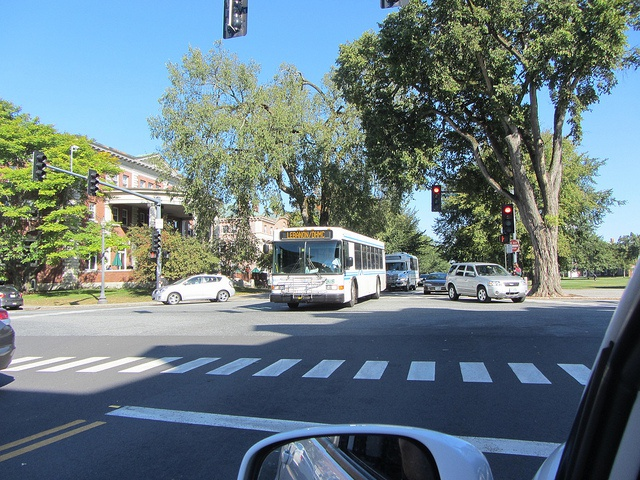Describe the objects in this image and their specific colors. I can see car in lightblue, black, gray, and darkgray tones, bus in lightblue, white, gray, black, and darkgray tones, car in lightblue, darkgray, lightgray, black, and gray tones, truck in lightblue, darkgray, lightgray, black, and gray tones, and car in lightblue, white, darkgray, and gray tones in this image. 